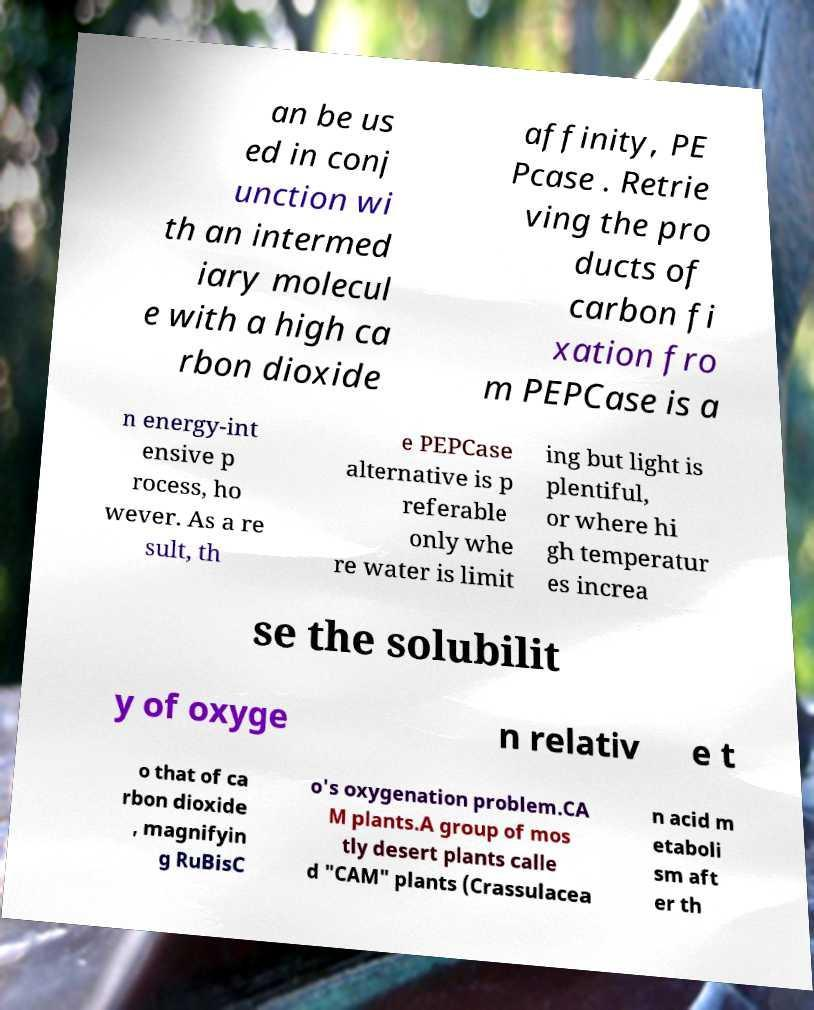What messages or text are displayed in this image? I need them in a readable, typed format. an be us ed in conj unction wi th an intermed iary molecul e with a high ca rbon dioxide affinity, PE Pcase . Retrie ving the pro ducts of carbon fi xation fro m PEPCase is a n energy-int ensive p rocess, ho wever. As a re sult, th e PEPCase alternative is p referable only whe re water is limit ing but light is plentiful, or where hi gh temperatur es increa se the solubilit y of oxyge n relativ e t o that of ca rbon dioxide , magnifyin g RuBisC o's oxygenation problem.CA M plants.A group of mos tly desert plants calle d "CAM" plants (Crassulacea n acid m etaboli sm aft er th 